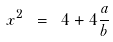<formula> <loc_0><loc_0><loc_500><loc_500>x ^ { 2 } \ = \ 4 + 4 \frac { a } { b }</formula> 